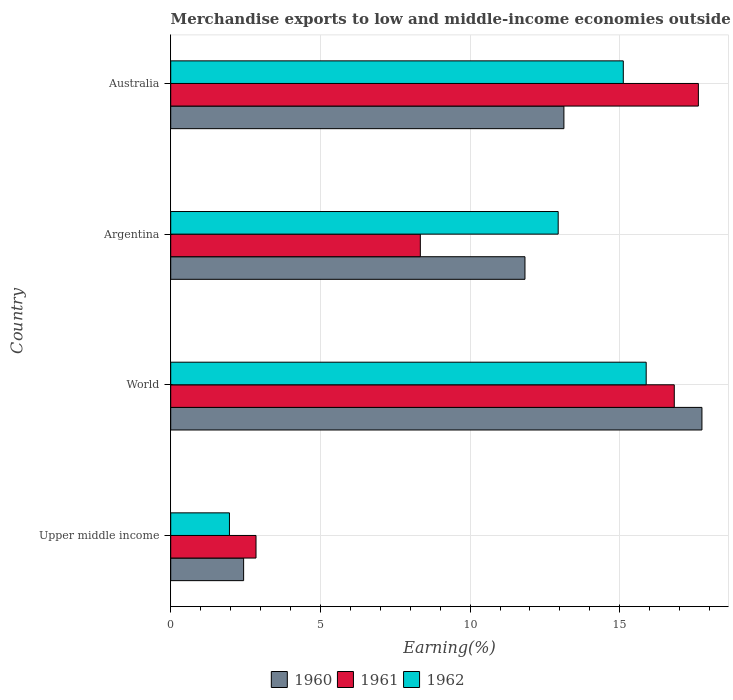How many groups of bars are there?
Ensure brevity in your answer.  4. How many bars are there on the 1st tick from the top?
Provide a short and direct response. 3. What is the percentage of amount earned from merchandise exports in 1960 in World?
Make the answer very short. 17.75. Across all countries, what is the maximum percentage of amount earned from merchandise exports in 1961?
Your answer should be very brief. 17.63. Across all countries, what is the minimum percentage of amount earned from merchandise exports in 1960?
Give a very brief answer. 2.44. In which country was the percentage of amount earned from merchandise exports in 1962 maximum?
Your answer should be compact. World. In which country was the percentage of amount earned from merchandise exports in 1961 minimum?
Your answer should be very brief. Upper middle income. What is the total percentage of amount earned from merchandise exports in 1962 in the graph?
Offer a very short reply. 45.91. What is the difference between the percentage of amount earned from merchandise exports in 1962 in Upper middle income and that in World?
Ensure brevity in your answer.  -13.92. What is the difference between the percentage of amount earned from merchandise exports in 1960 in World and the percentage of amount earned from merchandise exports in 1961 in Australia?
Offer a very short reply. 0.12. What is the average percentage of amount earned from merchandise exports in 1961 per country?
Provide a succinct answer. 11.41. What is the difference between the percentage of amount earned from merchandise exports in 1961 and percentage of amount earned from merchandise exports in 1960 in Australia?
Give a very brief answer. 4.49. In how many countries, is the percentage of amount earned from merchandise exports in 1961 greater than 14 %?
Provide a succinct answer. 2. What is the ratio of the percentage of amount earned from merchandise exports in 1960 in Upper middle income to that in World?
Your answer should be compact. 0.14. Is the percentage of amount earned from merchandise exports in 1961 in Australia less than that in Upper middle income?
Your response must be concise. No. Is the difference between the percentage of amount earned from merchandise exports in 1961 in Upper middle income and World greater than the difference between the percentage of amount earned from merchandise exports in 1960 in Upper middle income and World?
Keep it short and to the point. Yes. What is the difference between the highest and the second highest percentage of amount earned from merchandise exports in 1961?
Provide a succinct answer. 0.8. What is the difference between the highest and the lowest percentage of amount earned from merchandise exports in 1961?
Give a very brief answer. 14.78. What does the 1st bar from the top in World represents?
Your response must be concise. 1962. What is the difference between two consecutive major ticks on the X-axis?
Offer a very short reply. 5. Where does the legend appear in the graph?
Ensure brevity in your answer.  Bottom center. How are the legend labels stacked?
Make the answer very short. Horizontal. What is the title of the graph?
Your response must be concise. Merchandise exports to low and middle-income economies outside region. Does "1988" appear as one of the legend labels in the graph?
Give a very brief answer. No. What is the label or title of the X-axis?
Your answer should be compact. Earning(%). What is the Earning(%) in 1960 in Upper middle income?
Provide a short and direct response. 2.44. What is the Earning(%) of 1961 in Upper middle income?
Provide a short and direct response. 2.85. What is the Earning(%) in 1962 in Upper middle income?
Your answer should be compact. 1.96. What is the Earning(%) of 1960 in World?
Provide a short and direct response. 17.75. What is the Earning(%) of 1961 in World?
Keep it short and to the point. 16.82. What is the Earning(%) in 1962 in World?
Provide a short and direct response. 15.88. What is the Earning(%) in 1960 in Argentina?
Your response must be concise. 11.83. What is the Earning(%) in 1961 in Argentina?
Make the answer very short. 8.34. What is the Earning(%) in 1962 in Argentina?
Provide a succinct answer. 12.94. What is the Earning(%) of 1960 in Australia?
Offer a very short reply. 13.13. What is the Earning(%) in 1961 in Australia?
Keep it short and to the point. 17.63. What is the Earning(%) in 1962 in Australia?
Offer a terse response. 15.12. Across all countries, what is the maximum Earning(%) in 1960?
Make the answer very short. 17.75. Across all countries, what is the maximum Earning(%) of 1961?
Your response must be concise. 17.63. Across all countries, what is the maximum Earning(%) in 1962?
Your answer should be very brief. 15.88. Across all countries, what is the minimum Earning(%) of 1960?
Provide a short and direct response. 2.44. Across all countries, what is the minimum Earning(%) of 1961?
Your answer should be compact. 2.85. Across all countries, what is the minimum Earning(%) of 1962?
Ensure brevity in your answer.  1.96. What is the total Earning(%) in 1960 in the graph?
Your answer should be very brief. 45.15. What is the total Earning(%) in 1961 in the graph?
Offer a terse response. 45.64. What is the total Earning(%) in 1962 in the graph?
Your response must be concise. 45.91. What is the difference between the Earning(%) of 1960 in Upper middle income and that in World?
Ensure brevity in your answer.  -15.31. What is the difference between the Earning(%) of 1961 in Upper middle income and that in World?
Offer a very short reply. -13.97. What is the difference between the Earning(%) in 1962 in Upper middle income and that in World?
Provide a short and direct response. -13.92. What is the difference between the Earning(%) in 1960 in Upper middle income and that in Argentina?
Offer a very short reply. -9.4. What is the difference between the Earning(%) of 1961 in Upper middle income and that in Argentina?
Give a very brief answer. -5.49. What is the difference between the Earning(%) in 1962 in Upper middle income and that in Argentina?
Provide a short and direct response. -10.98. What is the difference between the Earning(%) in 1960 in Upper middle income and that in Australia?
Make the answer very short. -10.7. What is the difference between the Earning(%) in 1961 in Upper middle income and that in Australia?
Give a very brief answer. -14.78. What is the difference between the Earning(%) in 1962 in Upper middle income and that in Australia?
Offer a terse response. -13.16. What is the difference between the Earning(%) of 1960 in World and that in Argentina?
Offer a very short reply. 5.91. What is the difference between the Earning(%) in 1961 in World and that in Argentina?
Your answer should be compact. 8.48. What is the difference between the Earning(%) in 1962 in World and that in Argentina?
Provide a short and direct response. 2.94. What is the difference between the Earning(%) in 1960 in World and that in Australia?
Keep it short and to the point. 4.61. What is the difference between the Earning(%) of 1961 in World and that in Australia?
Your answer should be very brief. -0.8. What is the difference between the Earning(%) of 1962 in World and that in Australia?
Provide a short and direct response. 0.76. What is the difference between the Earning(%) of 1960 in Argentina and that in Australia?
Your response must be concise. -1.3. What is the difference between the Earning(%) in 1961 in Argentina and that in Australia?
Make the answer very short. -9.29. What is the difference between the Earning(%) in 1962 in Argentina and that in Australia?
Your response must be concise. -2.18. What is the difference between the Earning(%) of 1960 in Upper middle income and the Earning(%) of 1961 in World?
Offer a very short reply. -14.39. What is the difference between the Earning(%) of 1960 in Upper middle income and the Earning(%) of 1962 in World?
Your response must be concise. -13.45. What is the difference between the Earning(%) in 1961 in Upper middle income and the Earning(%) in 1962 in World?
Ensure brevity in your answer.  -13.03. What is the difference between the Earning(%) of 1960 in Upper middle income and the Earning(%) of 1961 in Argentina?
Your answer should be very brief. -5.9. What is the difference between the Earning(%) of 1960 in Upper middle income and the Earning(%) of 1962 in Argentina?
Your response must be concise. -10.51. What is the difference between the Earning(%) of 1961 in Upper middle income and the Earning(%) of 1962 in Argentina?
Offer a terse response. -10.09. What is the difference between the Earning(%) of 1960 in Upper middle income and the Earning(%) of 1961 in Australia?
Make the answer very short. -15.19. What is the difference between the Earning(%) of 1960 in Upper middle income and the Earning(%) of 1962 in Australia?
Ensure brevity in your answer.  -12.68. What is the difference between the Earning(%) in 1961 in Upper middle income and the Earning(%) in 1962 in Australia?
Keep it short and to the point. -12.27. What is the difference between the Earning(%) of 1960 in World and the Earning(%) of 1961 in Argentina?
Your answer should be very brief. 9.41. What is the difference between the Earning(%) of 1960 in World and the Earning(%) of 1962 in Argentina?
Keep it short and to the point. 4.8. What is the difference between the Earning(%) of 1961 in World and the Earning(%) of 1962 in Argentina?
Offer a terse response. 3.88. What is the difference between the Earning(%) in 1960 in World and the Earning(%) in 1961 in Australia?
Make the answer very short. 0.12. What is the difference between the Earning(%) in 1960 in World and the Earning(%) in 1962 in Australia?
Your response must be concise. 2.63. What is the difference between the Earning(%) of 1961 in World and the Earning(%) of 1962 in Australia?
Your answer should be compact. 1.7. What is the difference between the Earning(%) of 1960 in Argentina and the Earning(%) of 1961 in Australia?
Offer a terse response. -5.79. What is the difference between the Earning(%) of 1960 in Argentina and the Earning(%) of 1962 in Australia?
Offer a terse response. -3.29. What is the difference between the Earning(%) of 1961 in Argentina and the Earning(%) of 1962 in Australia?
Provide a succinct answer. -6.78. What is the average Earning(%) of 1960 per country?
Provide a short and direct response. 11.29. What is the average Earning(%) in 1961 per country?
Ensure brevity in your answer.  11.41. What is the average Earning(%) in 1962 per country?
Provide a succinct answer. 11.48. What is the difference between the Earning(%) in 1960 and Earning(%) in 1961 in Upper middle income?
Provide a short and direct response. -0.41. What is the difference between the Earning(%) of 1960 and Earning(%) of 1962 in Upper middle income?
Make the answer very short. 0.47. What is the difference between the Earning(%) of 1961 and Earning(%) of 1962 in Upper middle income?
Your answer should be compact. 0.89. What is the difference between the Earning(%) in 1960 and Earning(%) in 1961 in World?
Give a very brief answer. 0.92. What is the difference between the Earning(%) in 1960 and Earning(%) in 1962 in World?
Offer a terse response. 1.86. What is the difference between the Earning(%) of 1961 and Earning(%) of 1962 in World?
Ensure brevity in your answer.  0.94. What is the difference between the Earning(%) in 1960 and Earning(%) in 1961 in Argentina?
Provide a short and direct response. 3.5. What is the difference between the Earning(%) of 1960 and Earning(%) of 1962 in Argentina?
Give a very brief answer. -1.11. What is the difference between the Earning(%) in 1961 and Earning(%) in 1962 in Argentina?
Provide a succinct answer. -4.61. What is the difference between the Earning(%) of 1960 and Earning(%) of 1961 in Australia?
Provide a succinct answer. -4.49. What is the difference between the Earning(%) of 1960 and Earning(%) of 1962 in Australia?
Offer a very short reply. -1.98. What is the difference between the Earning(%) in 1961 and Earning(%) in 1962 in Australia?
Make the answer very short. 2.51. What is the ratio of the Earning(%) in 1960 in Upper middle income to that in World?
Ensure brevity in your answer.  0.14. What is the ratio of the Earning(%) in 1961 in Upper middle income to that in World?
Offer a terse response. 0.17. What is the ratio of the Earning(%) in 1962 in Upper middle income to that in World?
Your response must be concise. 0.12. What is the ratio of the Earning(%) in 1960 in Upper middle income to that in Argentina?
Your answer should be very brief. 0.21. What is the ratio of the Earning(%) in 1961 in Upper middle income to that in Argentina?
Provide a succinct answer. 0.34. What is the ratio of the Earning(%) of 1962 in Upper middle income to that in Argentina?
Give a very brief answer. 0.15. What is the ratio of the Earning(%) in 1960 in Upper middle income to that in Australia?
Provide a short and direct response. 0.19. What is the ratio of the Earning(%) in 1961 in Upper middle income to that in Australia?
Ensure brevity in your answer.  0.16. What is the ratio of the Earning(%) of 1962 in Upper middle income to that in Australia?
Ensure brevity in your answer.  0.13. What is the ratio of the Earning(%) of 1960 in World to that in Argentina?
Your answer should be compact. 1.5. What is the ratio of the Earning(%) of 1961 in World to that in Argentina?
Keep it short and to the point. 2.02. What is the ratio of the Earning(%) in 1962 in World to that in Argentina?
Provide a short and direct response. 1.23. What is the ratio of the Earning(%) in 1960 in World to that in Australia?
Your answer should be compact. 1.35. What is the ratio of the Earning(%) of 1961 in World to that in Australia?
Provide a succinct answer. 0.95. What is the ratio of the Earning(%) of 1962 in World to that in Australia?
Make the answer very short. 1.05. What is the ratio of the Earning(%) of 1960 in Argentina to that in Australia?
Your answer should be compact. 0.9. What is the ratio of the Earning(%) of 1961 in Argentina to that in Australia?
Make the answer very short. 0.47. What is the ratio of the Earning(%) of 1962 in Argentina to that in Australia?
Give a very brief answer. 0.86. What is the difference between the highest and the second highest Earning(%) in 1960?
Offer a terse response. 4.61. What is the difference between the highest and the second highest Earning(%) in 1961?
Offer a terse response. 0.8. What is the difference between the highest and the second highest Earning(%) of 1962?
Offer a very short reply. 0.76. What is the difference between the highest and the lowest Earning(%) of 1960?
Provide a succinct answer. 15.31. What is the difference between the highest and the lowest Earning(%) of 1961?
Keep it short and to the point. 14.78. What is the difference between the highest and the lowest Earning(%) in 1962?
Offer a terse response. 13.92. 